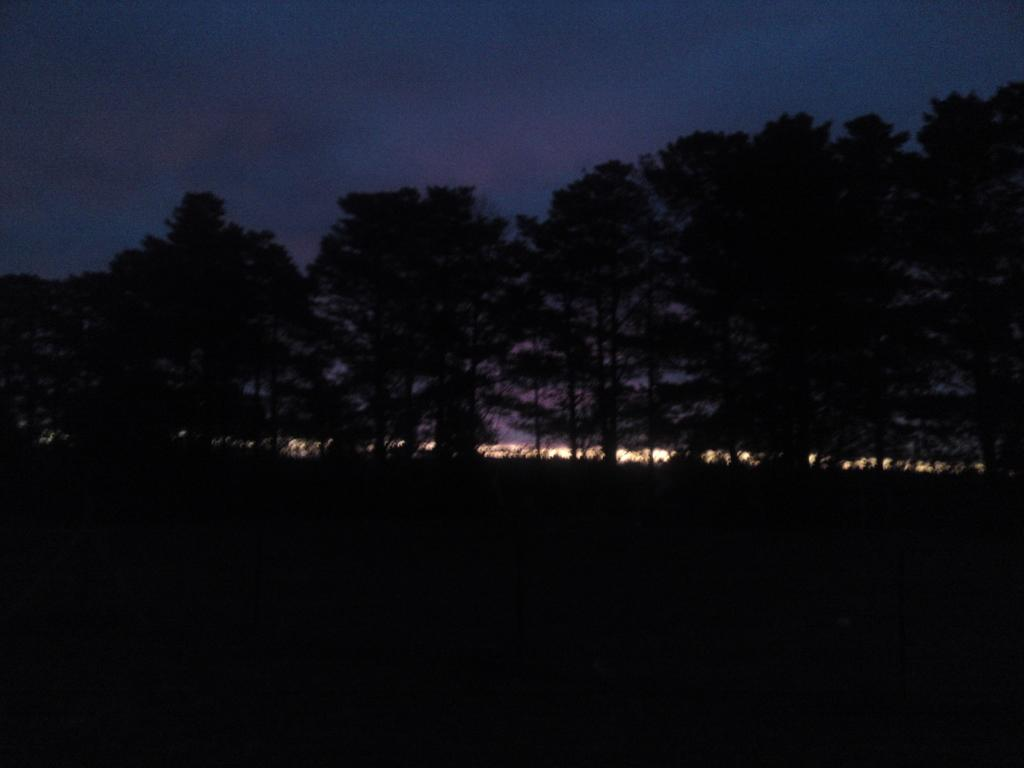What can be seen at the top of the image? The sky is visible in the image. What type of vegetation is present in the image? There are trees in the image. Where is the yam stored in the image? There is no yam present in the image. What type of frame surrounds the image? The image does not show a frame; it only shows the sky and trees. --- 